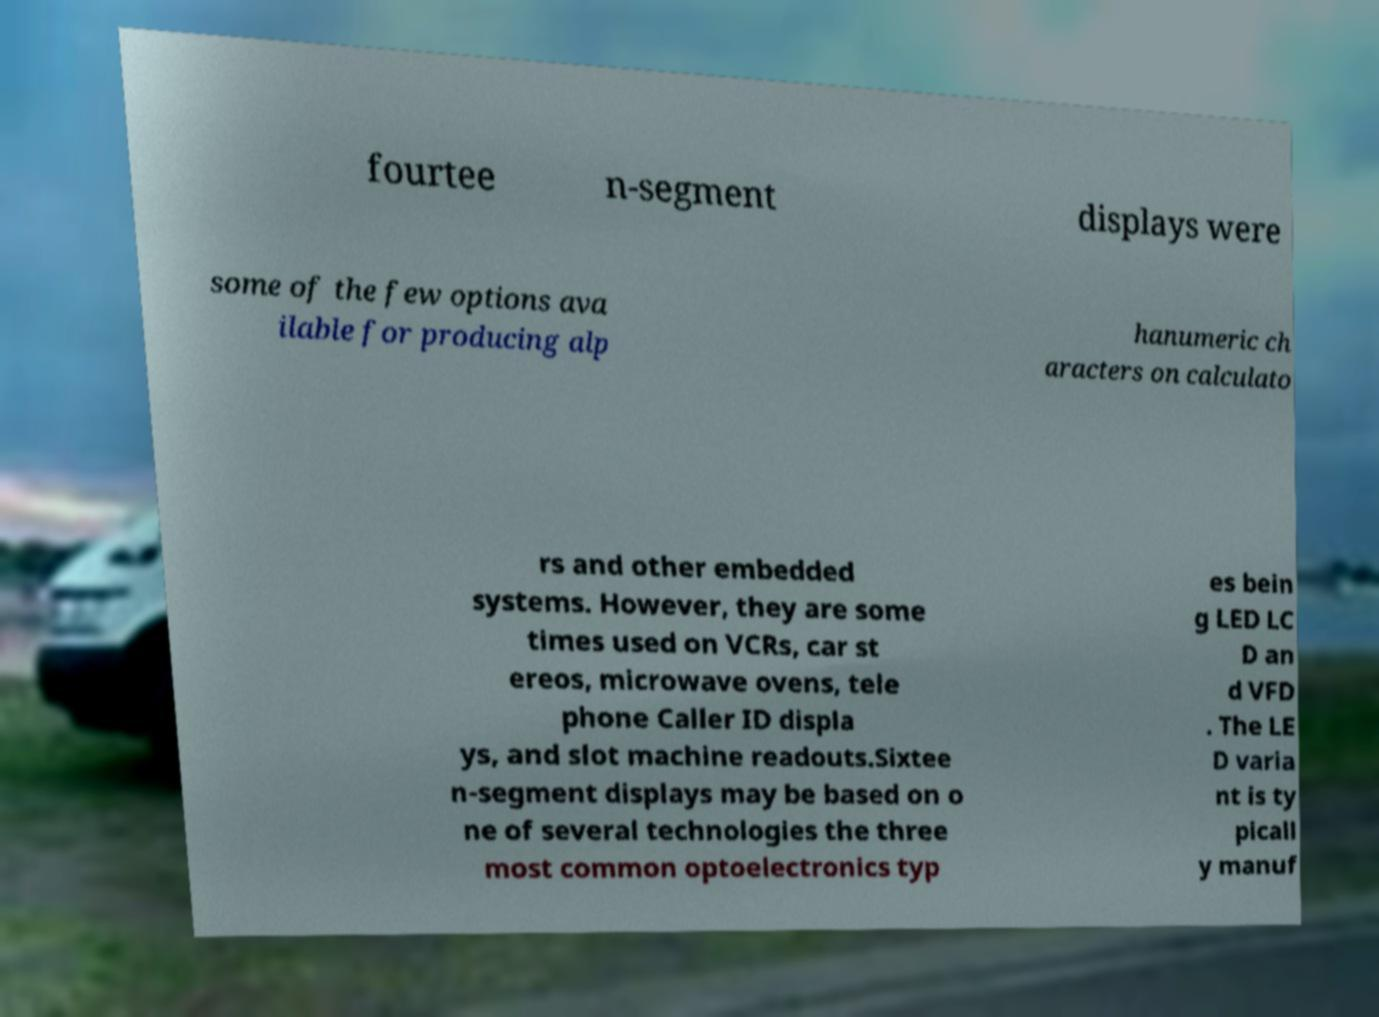Could you assist in decoding the text presented in this image and type it out clearly? fourtee n-segment displays were some of the few options ava ilable for producing alp hanumeric ch aracters on calculato rs and other embedded systems. However, they are some times used on VCRs, car st ereos, microwave ovens, tele phone Caller ID displa ys, and slot machine readouts.Sixtee n-segment displays may be based on o ne of several technologies the three most common optoelectronics typ es bein g LED LC D an d VFD . The LE D varia nt is ty picall y manuf 